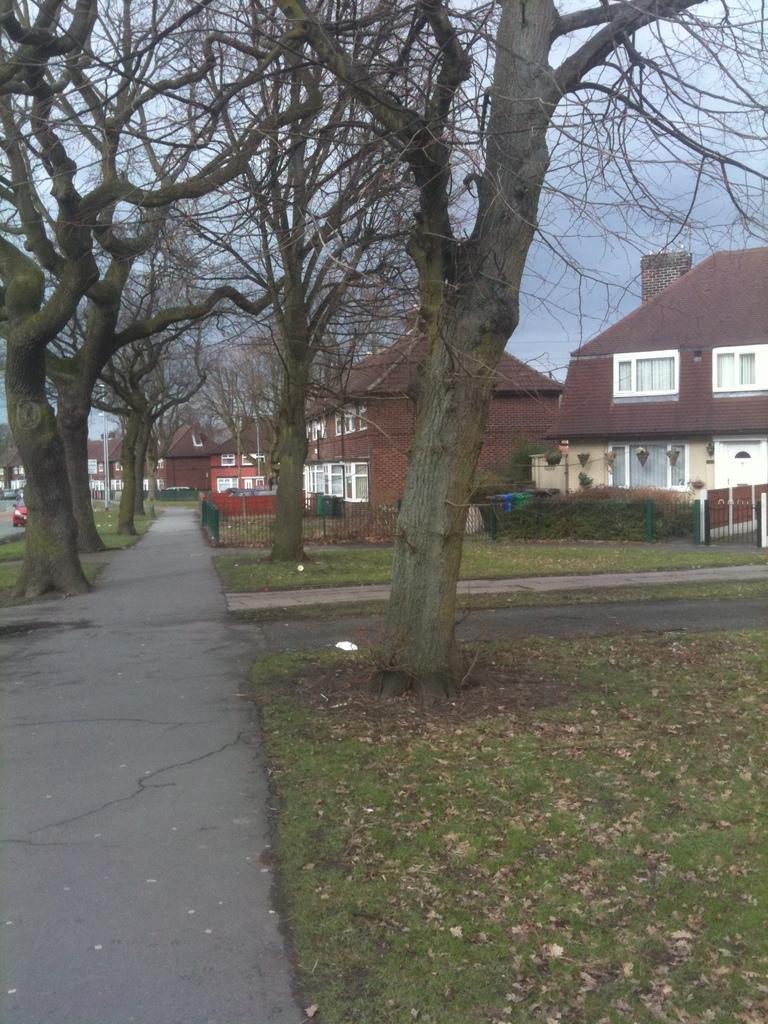Please provide a concise description of this image. In this picture we can see many buildings and trees. On the right there is a gate near to the plants. On the left there is a red color car which is parked near to the street lights. At the bottom we can see the leaves, grass and road. At the top there is a sky. 